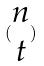<formula> <loc_0><loc_0><loc_500><loc_500>( \begin{matrix} n \\ t \end{matrix} )</formula> 